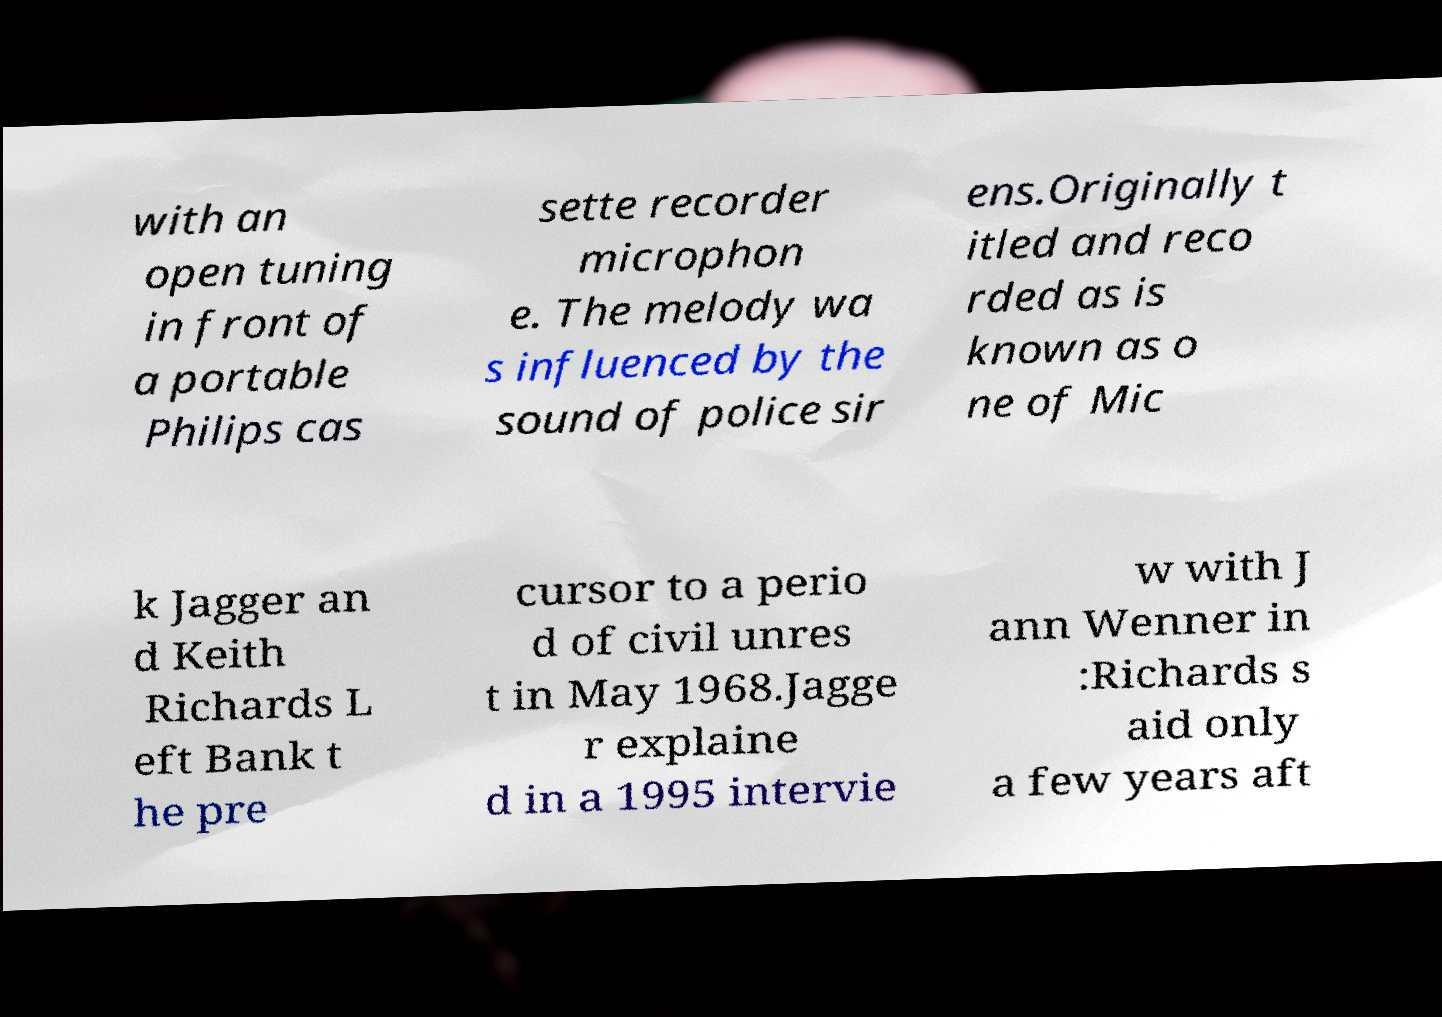Please read and relay the text visible in this image. What does it say? with an open tuning in front of a portable Philips cas sette recorder microphon e. The melody wa s influenced by the sound of police sir ens.Originally t itled and reco rded as is known as o ne of Mic k Jagger an d Keith Richards L eft Bank t he pre cursor to a perio d of civil unres t in May 1968.Jagge r explaine d in a 1995 intervie w with J ann Wenner in :Richards s aid only a few years aft 